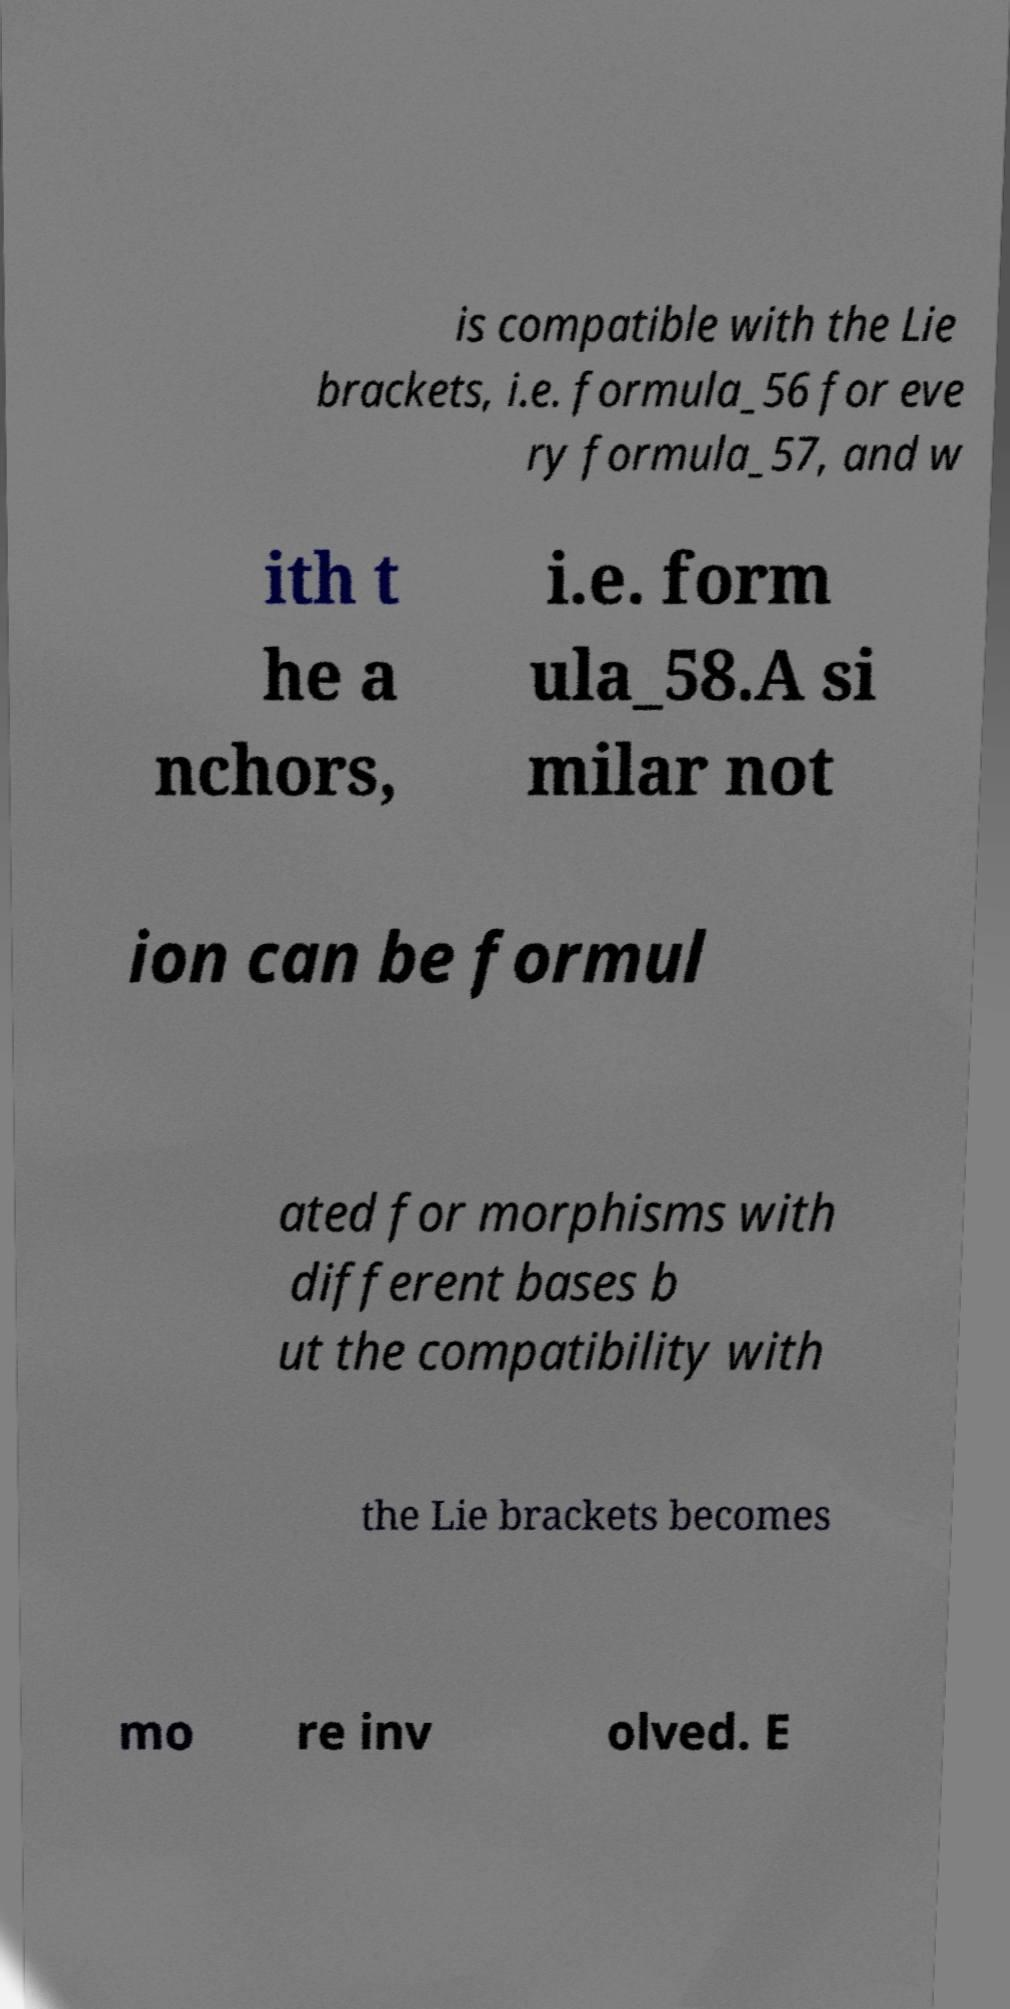What messages or text are displayed in this image? I need them in a readable, typed format. is compatible with the Lie brackets, i.e. formula_56 for eve ry formula_57, and w ith t he a nchors, i.e. form ula_58.A si milar not ion can be formul ated for morphisms with different bases b ut the compatibility with the Lie brackets becomes mo re inv olved. E 